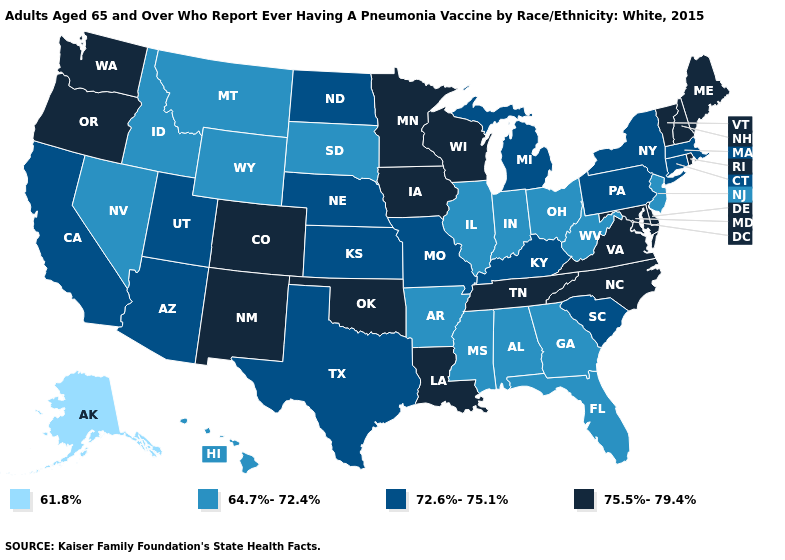What is the value of Vermont?
Give a very brief answer. 75.5%-79.4%. Does Georgia have the lowest value in the South?
Give a very brief answer. Yes. What is the value of Washington?
Short answer required. 75.5%-79.4%. Name the states that have a value in the range 72.6%-75.1%?
Give a very brief answer. Arizona, California, Connecticut, Kansas, Kentucky, Massachusetts, Michigan, Missouri, Nebraska, New York, North Dakota, Pennsylvania, South Carolina, Texas, Utah. Name the states that have a value in the range 61.8%?
Write a very short answer. Alaska. Does West Virginia have the highest value in the South?
Answer briefly. No. What is the highest value in the MidWest ?
Give a very brief answer. 75.5%-79.4%. What is the value of Florida?
Be succinct. 64.7%-72.4%. What is the value of West Virginia?
Quick response, please. 64.7%-72.4%. What is the lowest value in states that border Georgia?
Give a very brief answer. 64.7%-72.4%. What is the lowest value in states that border Minnesota?
Write a very short answer. 64.7%-72.4%. Does Alaska have the lowest value in the USA?
Write a very short answer. Yes. What is the value of Massachusetts?
Short answer required. 72.6%-75.1%. Name the states that have a value in the range 64.7%-72.4%?
Write a very short answer. Alabama, Arkansas, Florida, Georgia, Hawaii, Idaho, Illinois, Indiana, Mississippi, Montana, Nevada, New Jersey, Ohio, South Dakota, West Virginia, Wyoming. 